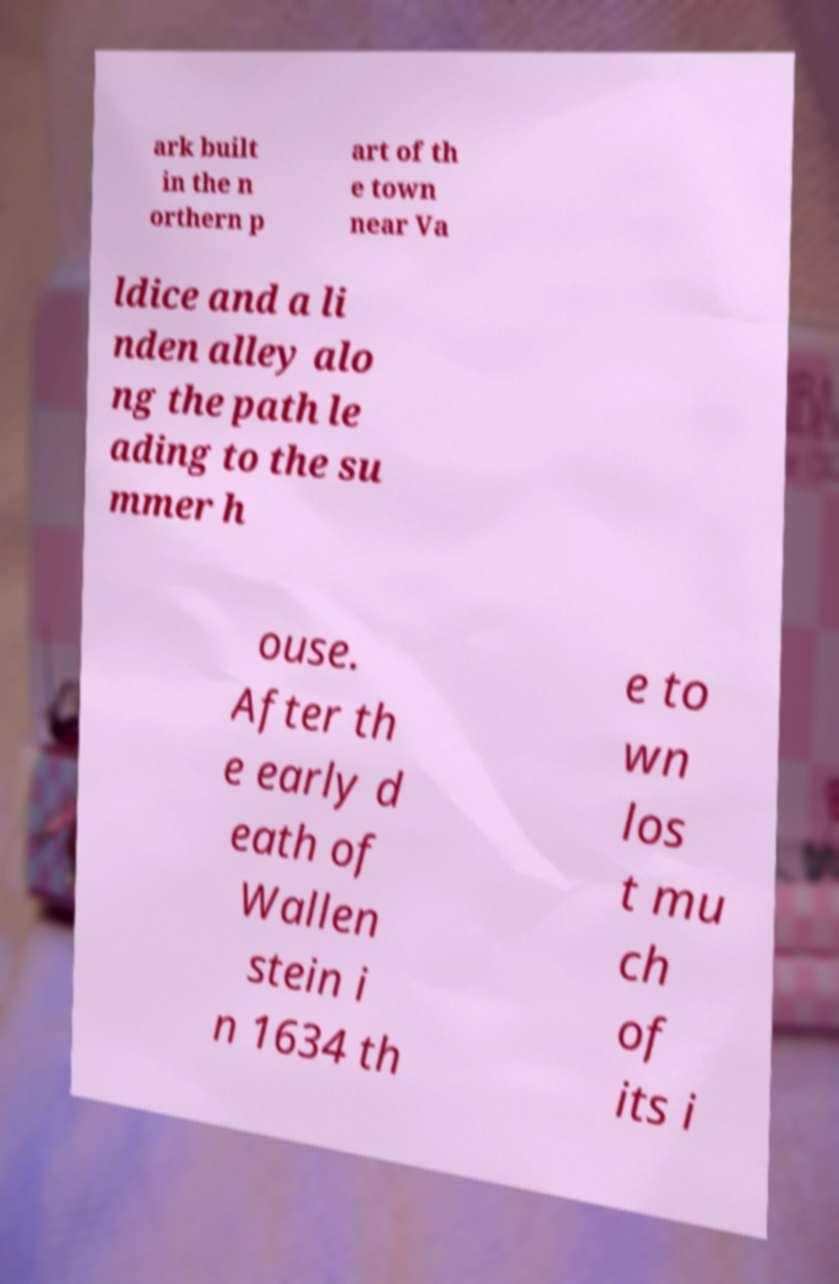Can you read and provide the text displayed in the image?This photo seems to have some interesting text. Can you extract and type it out for me? ark built in the n orthern p art of th e town near Va ldice and a li nden alley alo ng the path le ading to the su mmer h ouse. After th e early d eath of Wallen stein i n 1634 th e to wn los t mu ch of its i 